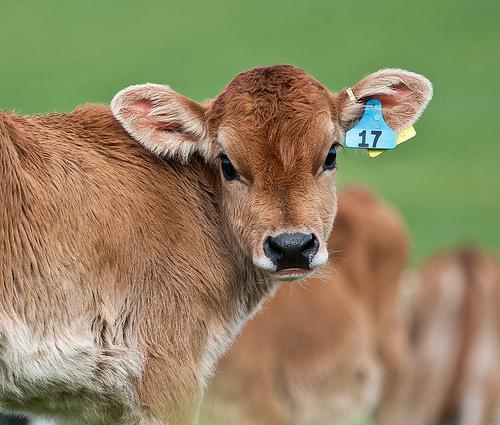How many animals with 17 tag on ear?
Give a very brief answer. 1. 